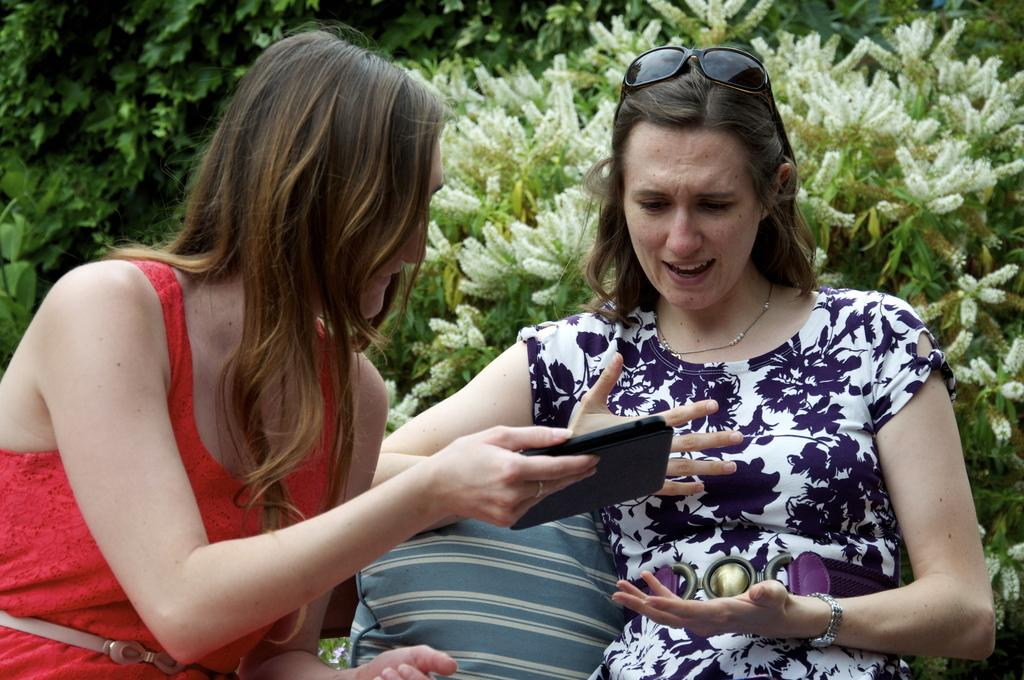How many people are sitting in the image? There are two women sitting in the image. What is between the two women? There is a pillow between the two women. What is the woman on the left holding? The woman on the left is holding a mobile phone. What can be seen in the background of the image? There are plants visible in the background of the image. What type of stove is visible in the image? There is no stove present in the image. What kind of laborer can be seen working in the background of the image? There is no laborer present in the image; it only features two women sitting with a pillow between them and plants in the background. 